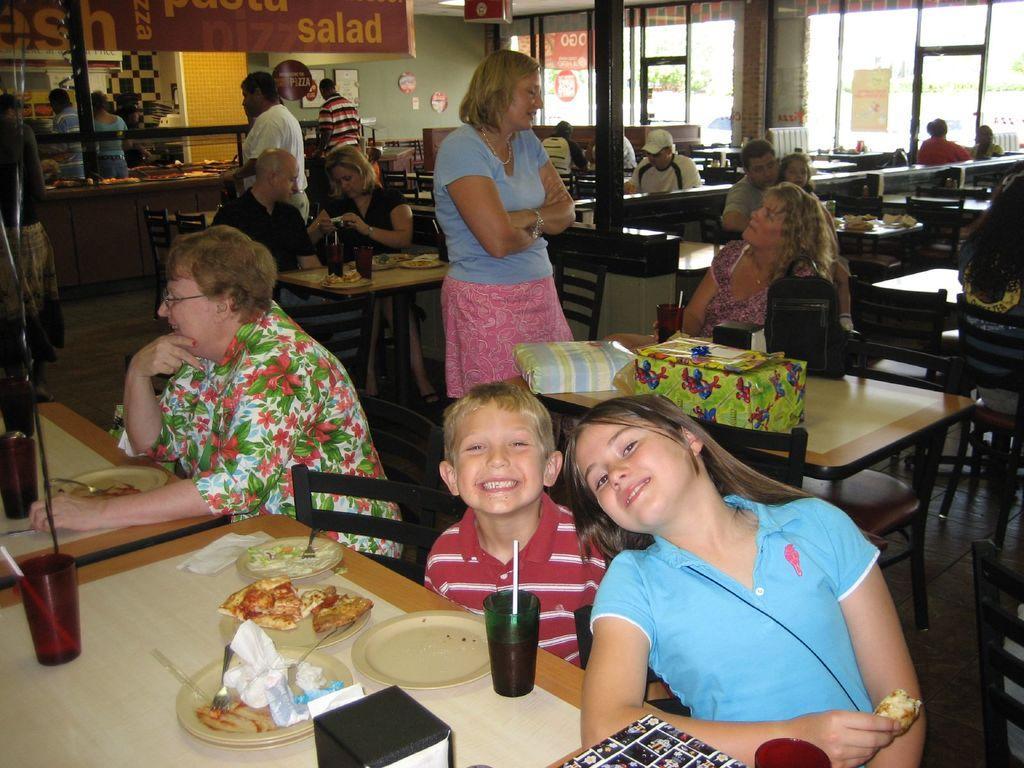How would you summarize this image in a sentence or two? This is a picture taken in a restaurant, there are a group of people sitting on chairs in front of these people there is a table on the table there are gift boxes, glasses, plates, tissues, spoon, and food items. Behind the people there is a wall, glass doors. 